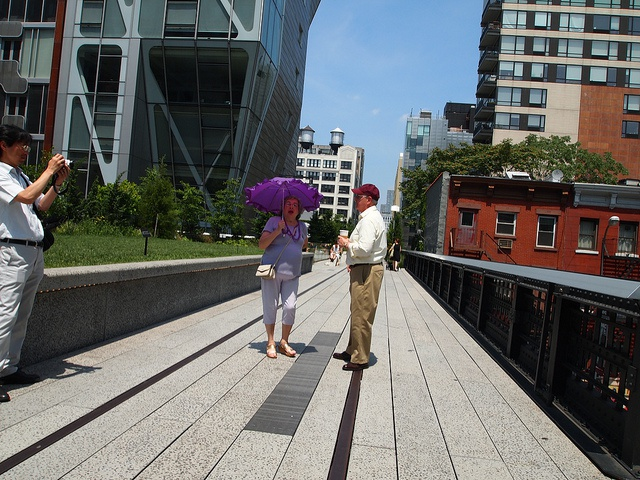Describe the objects in this image and their specific colors. I can see people in black, gray, lightgray, and maroon tones, people in black, white, gray, and maroon tones, people in black, gray, and maroon tones, umbrella in black, purple, and navy tones, and handbag in black, gray, ivory, and darkgray tones in this image. 